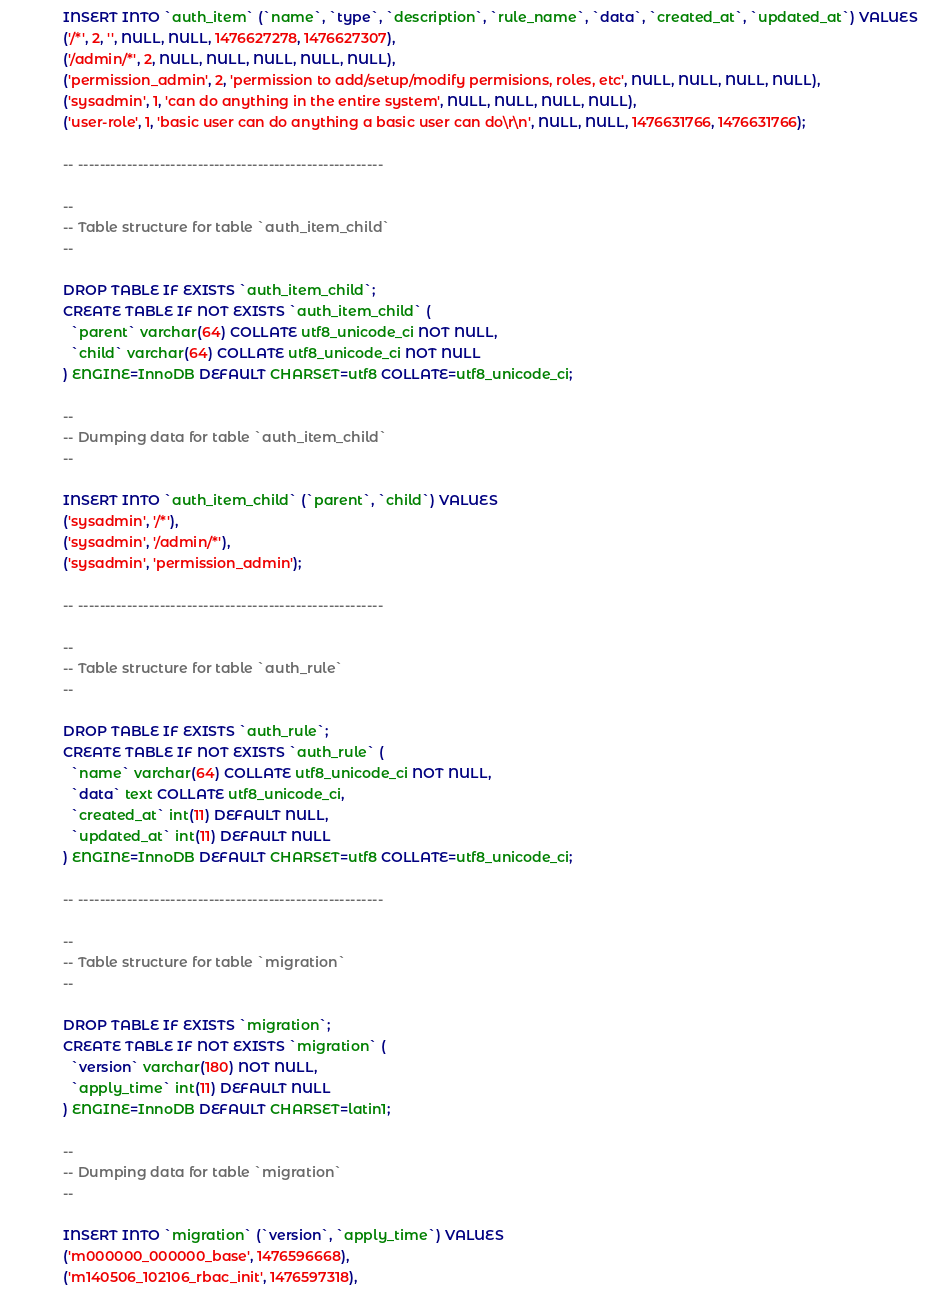<code> <loc_0><loc_0><loc_500><loc_500><_SQL_>
INSERT INTO `auth_item` (`name`, `type`, `description`, `rule_name`, `data`, `created_at`, `updated_at`) VALUES
('/*', 2, '', NULL, NULL, 1476627278, 1476627307),
('/admin/*', 2, NULL, NULL, NULL, NULL, NULL),
('permission_admin', 2, 'permission to add/setup/modify permisions, roles, etc', NULL, NULL, NULL, NULL),
('sysadmin', 1, 'can do anything in the entire system', NULL, NULL, NULL, NULL),
('user-role', 1, 'basic user can do anything a basic user can do\r\n', NULL, NULL, 1476631766, 1476631766);

-- --------------------------------------------------------

--
-- Table structure for table `auth_item_child`
--

DROP TABLE IF EXISTS `auth_item_child`;
CREATE TABLE IF NOT EXISTS `auth_item_child` (
  `parent` varchar(64) COLLATE utf8_unicode_ci NOT NULL,
  `child` varchar(64) COLLATE utf8_unicode_ci NOT NULL
) ENGINE=InnoDB DEFAULT CHARSET=utf8 COLLATE=utf8_unicode_ci;

--
-- Dumping data for table `auth_item_child`
--

INSERT INTO `auth_item_child` (`parent`, `child`) VALUES
('sysadmin', '/*'),
('sysadmin', '/admin/*'),
('sysadmin', 'permission_admin');

-- --------------------------------------------------------

--
-- Table structure for table `auth_rule`
--

DROP TABLE IF EXISTS `auth_rule`;
CREATE TABLE IF NOT EXISTS `auth_rule` (
  `name` varchar(64) COLLATE utf8_unicode_ci NOT NULL,
  `data` text COLLATE utf8_unicode_ci,
  `created_at` int(11) DEFAULT NULL,
  `updated_at` int(11) DEFAULT NULL
) ENGINE=InnoDB DEFAULT CHARSET=utf8 COLLATE=utf8_unicode_ci;

-- --------------------------------------------------------

--
-- Table structure for table `migration`
--

DROP TABLE IF EXISTS `migration`;
CREATE TABLE IF NOT EXISTS `migration` (
  `version` varchar(180) NOT NULL,
  `apply_time` int(11) DEFAULT NULL
) ENGINE=InnoDB DEFAULT CHARSET=latin1;

--
-- Dumping data for table `migration`
--

INSERT INTO `migration` (`version`, `apply_time`) VALUES
('m000000_000000_base', 1476596668),
('m140506_102106_rbac_init', 1476597318),</code> 